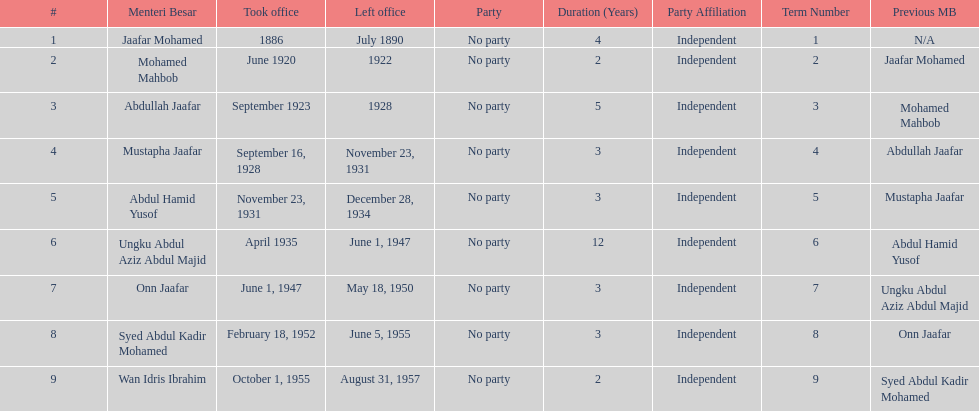Name someone who was not in office more than 4 years. Mohamed Mahbob. 